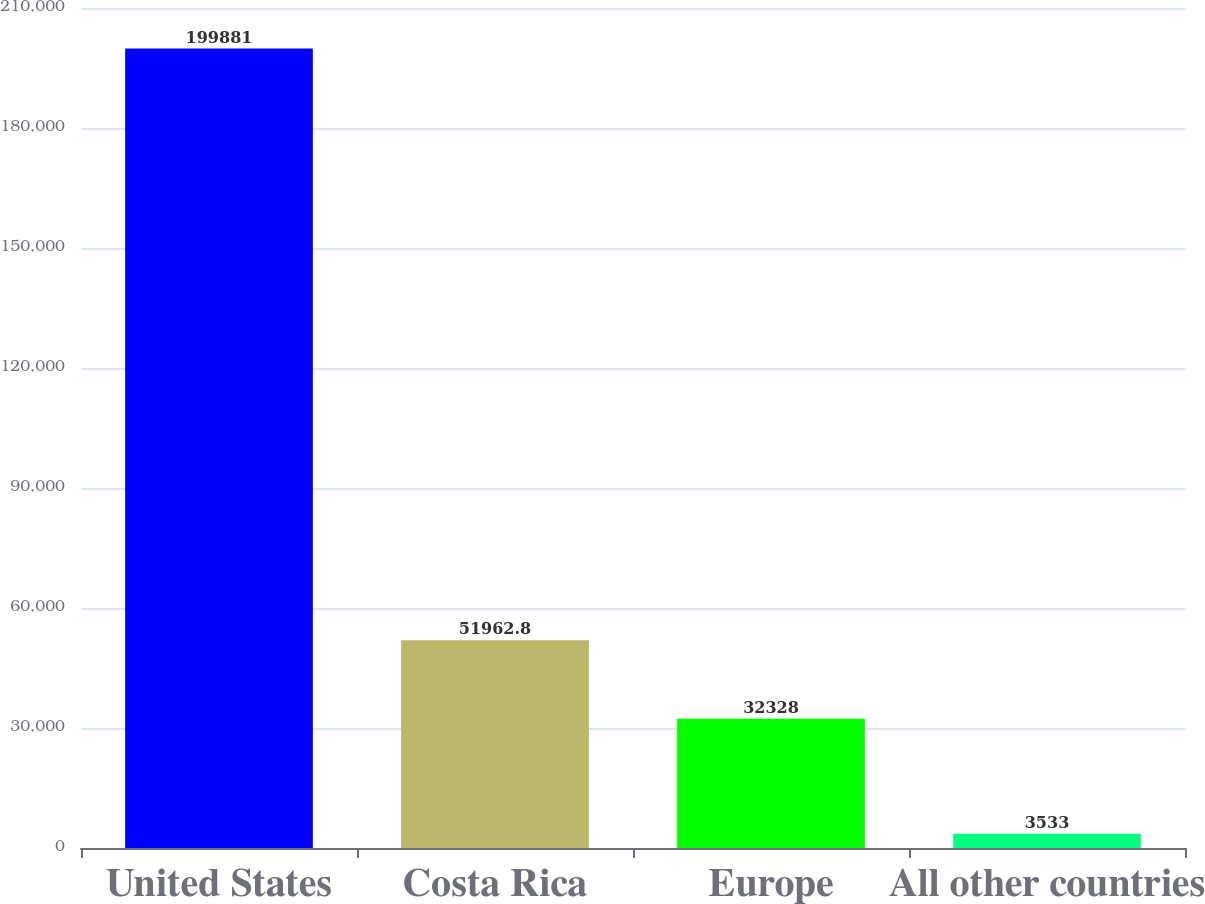Convert chart. <chart><loc_0><loc_0><loc_500><loc_500><bar_chart><fcel>United States<fcel>Costa Rica<fcel>Europe<fcel>All other countries<nl><fcel>199881<fcel>51962.8<fcel>32328<fcel>3533<nl></chart> 